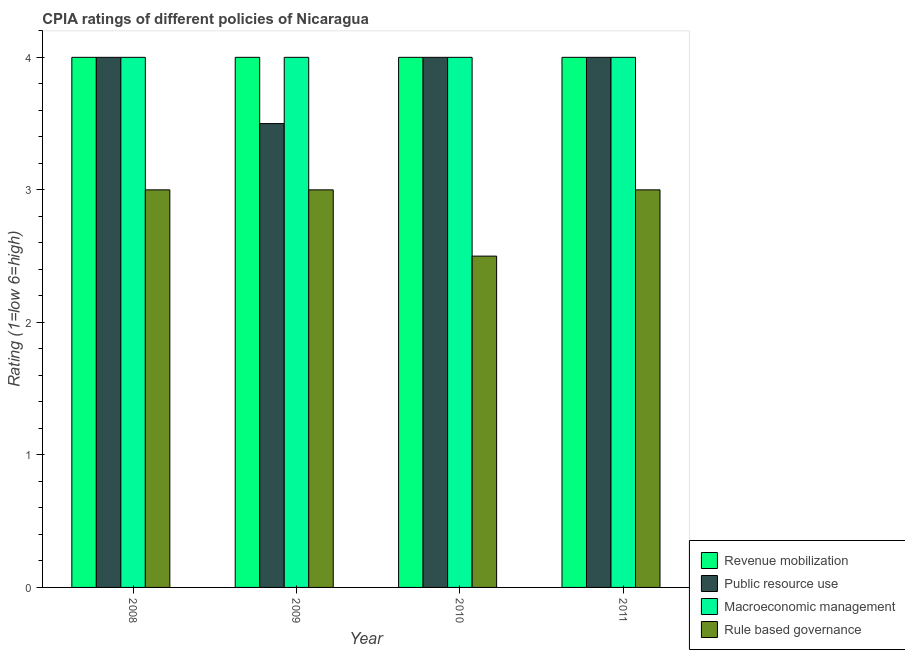Are the number of bars per tick equal to the number of legend labels?
Give a very brief answer. Yes. Across all years, what is the maximum cpia rating of public resource use?
Your response must be concise. 4. Across all years, what is the minimum cpia rating of public resource use?
Make the answer very short. 3.5. In which year was the cpia rating of public resource use maximum?
Give a very brief answer. 2008. In which year was the cpia rating of rule based governance minimum?
Make the answer very short. 2010. What is the difference between the cpia rating of public resource use in 2009 and that in 2011?
Provide a succinct answer. -0.5. What is the difference between the cpia rating of rule based governance in 2009 and the cpia rating of macroeconomic management in 2011?
Your answer should be very brief. 0. In the year 2010, what is the difference between the cpia rating of public resource use and cpia rating of macroeconomic management?
Your answer should be compact. 0. Is the difference between the cpia rating of public resource use in 2009 and 2010 greater than the difference between the cpia rating of rule based governance in 2009 and 2010?
Your answer should be very brief. No. What is the difference between the highest and the second highest cpia rating of public resource use?
Ensure brevity in your answer.  0. In how many years, is the cpia rating of rule based governance greater than the average cpia rating of rule based governance taken over all years?
Give a very brief answer. 3. Is the sum of the cpia rating of rule based governance in 2008 and 2010 greater than the maximum cpia rating of public resource use across all years?
Provide a short and direct response. Yes. Is it the case that in every year, the sum of the cpia rating of public resource use and cpia rating of revenue mobilization is greater than the sum of cpia rating of rule based governance and cpia rating of macroeconomic management?
Provide a succinct answer. No. What does the 4th bar from the left in 2011 represents?
Your response must be concise. Rule based governance. What does the 2nd bar from the right in 2008 represents?
Make the answer very short. Macroeconomic management. How many bars are there?
Your answer should be very brief. 16. Are all the bars in the graph horizontal?
Make the answer very short. No. What is the difference between two consecutive major ticks on the Y-axis?
Make the answer very short. 1. Are the values on the major ticks of Y-axis written in scientific E-notation?
Your answer should be very brief. No. How are the legend labels stacked?
Your answer should be very brief. Vertical. What is the title of the graph?
Provide a short and direct response. CPIA ratings of different policies of Nicaragua. Does "Australia" appear as one of the legend labels in the graph?
Offer a very short reply. No. What is the Rating (1=low 6=high) in Public resource use in 2008?
Provide a short and direct response. 4. What is the Rating (1=low 6=high) in Macroeconomic management in 2008?
Provide a succinct answer. 4. What is the Rating (1=low 6=high) in Revenue mobilization in 2009?
Ensure brevity in your answer.  4. What is the Rating (1=low 6=high) of Public resource use in 2009?
Offer a terse response. 3.5. What is the Rating (1=low 6=high) of Macroeconomic management in 2009?
Provide a succinct answer. 4. What is the Rating (1=low 6=high) of Revenue mobilization in 2010?
Keep it short and to the point. 4. What is the Rating (1=low 6=high) in Macroeconomic management in 2010?
Give a very brief answer. 4. What is the Rating (1=low 6=high) in Rule based governance in 2010?
Your response must be concise. 2.5. What is the Rating (1=low 6=high) in Public resource use in 2011?
Give a very brief answer. 4. What is the Rating (1=low 6=high) in Rule based governance in 2011?
Your answer should be very brief. 3. Across all years, what is the maximum Rating (1=low 6=high) in Public resource use?
Offer a very short reply. 4. Across all years, what is the maximum Rating (1=low 6=high) in Rule based governance?
Provide a succinct answer. 3. Across all years, what is the minimum Rating (1=low 6=high) in Revenue mobilization?
Keep it short and to the point. 4. Across all years, what is the minimum Rating (1=low 6=high) of Public resource use?
Keep it short and to the point. 3.5. Across all years, what is the minimum Rating (1=low 6=high) in Macroeconomic management?
Your answer should be compact. 4. What is the total Rating (1=low 6=high) in Rule based governance in the graph?
Keep it short and to the point. 11.5. What is the difference between the Rating (1=low 6=high) in Macroeconomic management in 2008 and that in 2009?
Your answer should be very brief. 0. What is the difference between the Rating (1=low 6=high) in Rule based governance in 2008 and that in 2009?
Your response must be concise. 0. What is the difference between the Rating (1=low 6=high) of Revenue mobilization in 2008 and that in 2010?
Provide a short and direct response. 0. What is the difference between the Rating (1=low 6=high) of Public resource use in 2008 and that in 2011?
Your answer should be very brief. 0. What is the difference between the Rating (1=low 6=high) in Macroeconomic management in 2008 and that in 2011?
Provide a succinct answer. 0. What is the difference between the Rating (1=low 6=high) in Rule based governance in 2008 and that in 2011?
Keep it short and to the point. 0. What is the difference between the Rating (1=low 6=high) of Revenue mobilization in 2009 and that in 2011?
Offer a very short reply. 0. What is the difference between the Rating (1=low 6=high) of Macroeconomic management in 2009 and that in 2011?
Ensure brevity in your answer.  0. What is the difference between the Rating (1=low 6=high) in Rule based governance in 2009 and that in 2011?
Provide a succinct answer. 0. What is the difference between the Rating (1=low 6=high) of Public resource use in 2010 and that in 2011?
Ensure brevity in your answer.  0. What is the difference between the Rating (1=low 6=high) in Rule based governance in 2010 and that in 2011?
Give a very brief answer. -0.5. What is the difference between the Rating (1=low 6=high) of Revenue mobilization in 2008 and the Rating (1=low 6=high) of Macroeconomic management in 2009?
Ensure brevity in your answer.  0. What is the difference between the Rating (1=low 6=high) in Public resource use in 2008 and the Rating (1=low 6=high) in Macroeconomic management in 2009?
Your answer should be very brief. 0. What is the difference between the Rating (1=low 6=high) in Public resource use in 2008 and the Rating (1=low 6=high) in Rule based governance in 2009?
Your response must be concise. 1. What is the difference between the Rating (1=low 6=high) of Macroeconomic management in 2008 and the Rating (1=low 6=high) of Rule based governance in 2009?
Your answer should be very brief. 1. What is the difference between the Rating (1=low 6=high) of Revenue mobilization in 2008 and the Rating (1=low 6=high) of Public resource use in 2010?
Offer a very short reply. 0. What is the difference between the Rating (1=low 6=high) of Revenue mobilization in 2008 and the Rating (1=low 6=high) of Macroeconomic management in 2010?
Provide a short and direct response. 0. What is the difference between the Rating (1=low 6=high) in Revenue mobilization in 2008 and the Rating (1=low 6=high) in Rule based governance in 2010?
Your answer should be very brief. 1.5. What is the difference between the Rating (1=low 6=high) in Revenue mobilization in 2008 and the Rating (1=low 6=high) in Macroeconomic management in 2011?
Ensure brevity in your answer.  0. What is the difference between the Rating (1=low 6=high) in Public resource use in 2008 and the Rating (1=low 6=high) in Macroeconomic management in 2011?
Your answer should be very brief. 0. What is the difference between the Rating (1=low 6=high) of Revenue mobilization in 2009 and the Rating (1=low 6=high) of Rule based governance in 2010?
Offer a very short reply. 1.5. What is the difference between the Rating (1=low 6=high) in Public resource use in 2009 and the Rating (1=low 6=high) in Macroeconomic management in 2010?
Keep it short and to the point. -0.5. What is the difference between the Rating (1=low 6=high) in Public resource use in 2009 and the Rating (1=low 6=high) in Rule based governance in 2010?
Provide a succinct answer. 1. What is the difference between the Rating (1=low 6=high) of Revenue mobilization in 2009 and the Rating (1=low 6=high) of Macroeconomic management in 2011?
Provide a short and direct response. 0. What is the difference between the Rating (1=low 6=high) of Revenue mobilization in 2010 and the Rating (1=low 6=high) of Public resource use in 2011?
Your response must be concise. 0. What is the difference between the Rating (1=low 6=high) in Revenue mobilization in 2010 and the Rating (1=low 6=high) in Macroeconomic management in 2011?
Offer a terse response. 0. What is the difference between the Rating (1=low 6=high) of Macroeconomic management in 2010 and the Rating (1=low 6=high) of Rule based governance in 2011?
Make the answer very short. 1. What is the average Rating (1=low 6=high) of Public resource use per year?
Your answer should be very brief. 3.88. What is the average Rating (1=low 6=high) in Macroeconomic management per year?
Offer a terse response. 4. What is the average Rating (1=low 6=high) in Rule based governance per year?
Provide a short and direct response. 2.88. In the year 2008, what is the difference between the Rating (1=low 6=high) of Revenue mobilization and Rating (1=low 6=high) of Public resource use?
Your answer should be compact. 0. In the year 2008, what is the difference between the Rating (1=low 6=high) of Revenue mobilization and Rating (1=low 6=high) of Macroeconomic management?
Provide a succinct answer. 0. In the year 2008, what is the difference between the Rating (1=low 6=high) in Revenue mobilization and Rating (1=low 6=high) in Rule based governance?
Your answer should be compact. 1. In the year 2009, what is the difference between the Rating (1=low 6=high) in Revenue mobilization and Rating (1=low 6=high) in Macroeconomic management?
Your response must be concise. 0. In the year 2009, what is the difference between the Rating (1=low 6=high) in Revenue mobilization and Rating (1=low 6=high) in Rule based governance?
Your answer should be compact. 1. In the year 2009, what is the difference between the Rating (1=low 6=high) in Public resource use and Rating (1=low 6=high) in Macroeconomic management?
Offer a terse response. -0.5. In the year 2009, what is the difference between the Rating (1=low 6=high) of Public resource use and Rating (1=low 6=high) of Rule based governance?
Your response must be concise. 0.5. In the year 2009, what is the difference between the Rating (1=low 6=high) of Macroeconomic management and Rating (1=low 6=high) of Rule based governance?
Ensure brevity in your answer.  1. In the year 2010, what is the difference between the Rating (1=low 6=high) in Public resource use and Rating (1=low 6=high) in Macroeconomic management?
Your answer should be compact. 0. In the year 2010, what is the difference between the Rating (1=low 6=high) in Macroeconomic management and Rating (1=low 6=high) in Rule based governance?
Your answer should be very brief. 1.5. In the year 2011, what is the difference between the Rating (1=low 6=high) in Public resource use and Rating (1=low 6=high) in Macroeconomic management?
Ensure brevity in your answer.  0. What is the ratio of the Rating (1=low 6=high) of Revenue mobilization in 2008 to that in 2010?
Your answer should be very brief. 1. What is the ratio of the Rating (1=low 6=high) in Macroeconomic management in 2008 to that in 2010?
Your response must be concise. 1. What is the ratio of the Rating (1=low 6=high) in Revenue mobilization in 2009 to that in 2010?
Your answer should be very brief. 1. What is the ratio of the Rating (1=low 6=high) in Public resource use in 2009 to that in 2010?
Offer a terse response. 0.88. What is the ratio of the Rating (1=low 6=high) in Revenue mobilization in 2009 to that in 2011?
Provide a succinct answer. 1. What is the ratio of the Rating (1=low 6=high) of Macroeconomic management in 2009 to that in 2011?
Offer a very short reply. 1. What is the ratio of the Rating (1=low 6=high) of Rule based governance in 2009 to that in 2011?
Offer a terse response. 1. What is the ratio of the Rating (1=low 6=high) of Revenue mobilization in 2010 to that in 2011?
Provide a short and direct response. 1. What is the ratio of the Rating (1=low 6=high) in Public resource use in 2010 to that in 2011?
Offer a very short reply. 1. What is the difference between the highest and the second highest Rating (1=low 6=high) of Revenue mobilization?
Give a very brief answer. 0. What is the difference between the highest and the second highest Rating (1=low 6=high) of Rule based governance?
Provide a succinct answer. 0. What is the difference between the highest and the lowest Rating (1=low 6=high) of Revenue mobilization?
Provide a short and direct response. 0. What is the difference between the highest and the lowest Rating (1=low 6=high) of Public resource use?
Your answer should be very brief. 0.5. What is the difference between the highest and the lowest Rating (1=low 6=high) of Macroeconomic management?
Your answer should be compact. 0. What is the difference between the highest and the lowest Rating (1=low 6=high) in Rule based governance?
Keep it short and to the point. 0.5. 